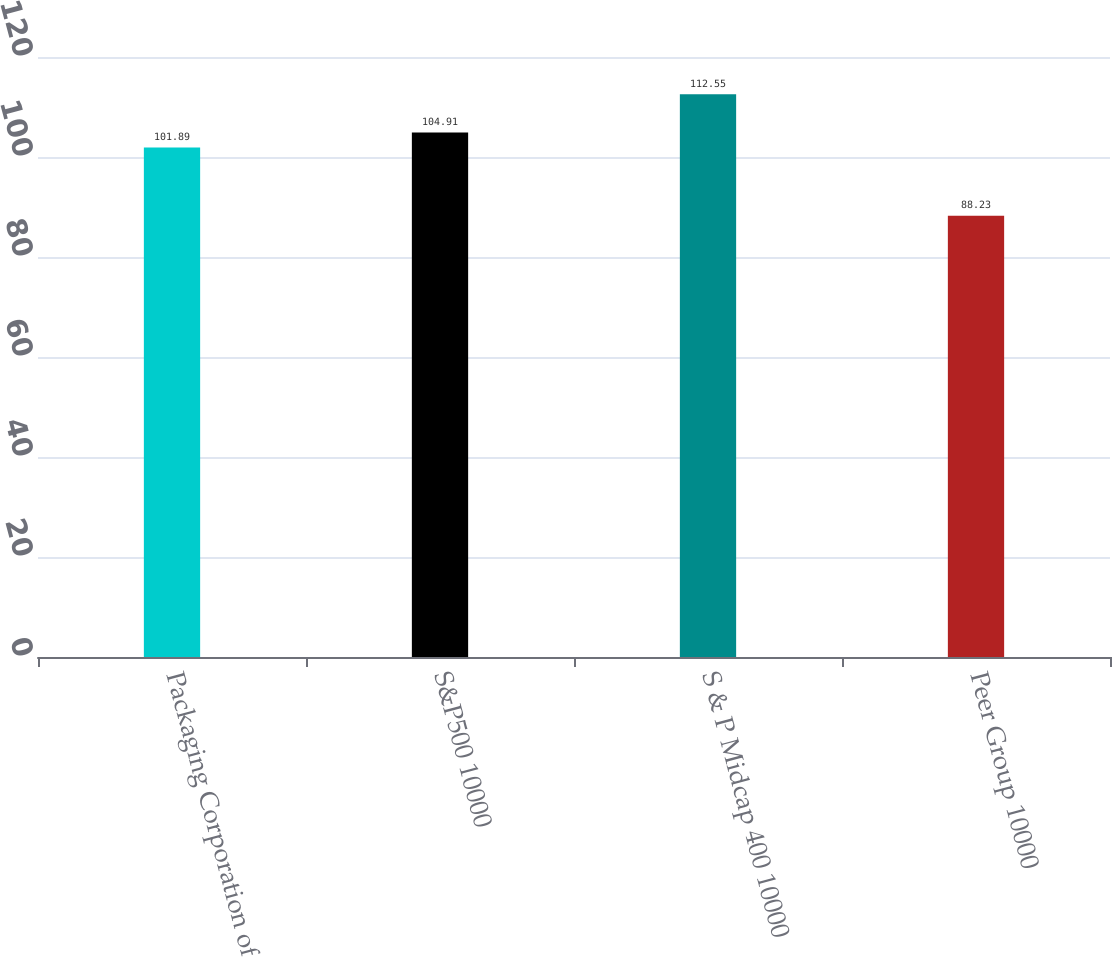<chart> <loc_0><loc_0><loc_500><loc_500><bar_chart><fcel>Packaging Corporation of<fcel>S&P500 10000<fcel>S & P Midcap 400 10000<fcel>Peer Group 10000<nl><fcel>101.89<fcel>104.91<fcel>112.55<fcel>88.23<nl></chart> 